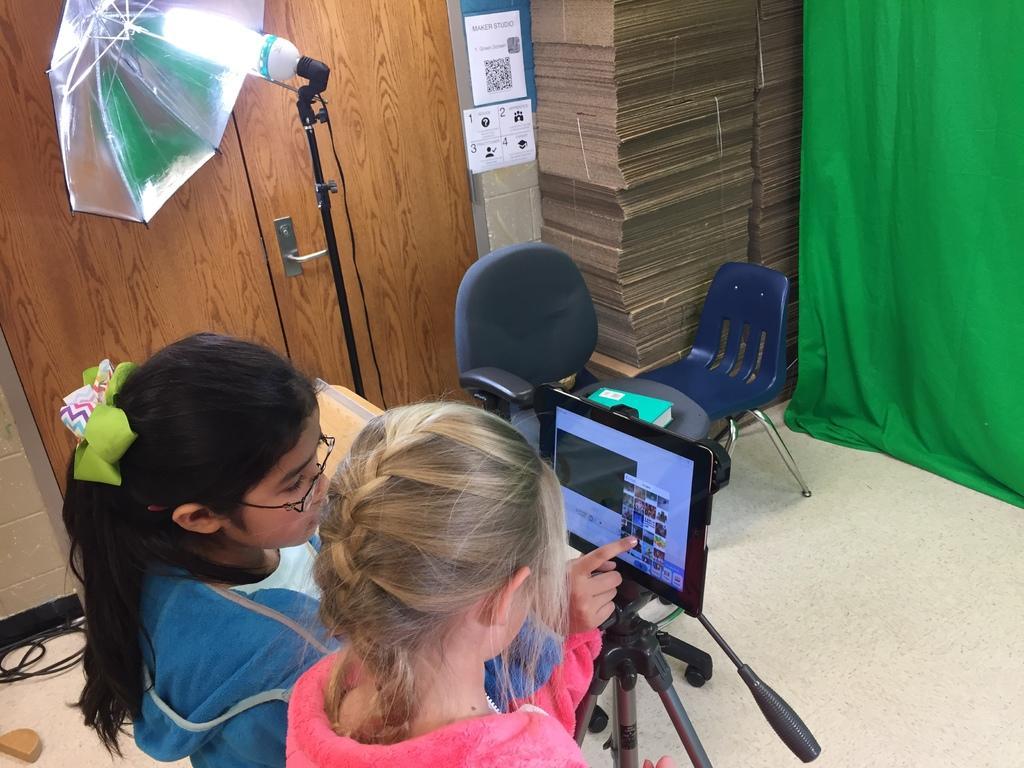In one or two sentences, can you explain what this image depicts? This 2 girls are looking at tab which is on tripod. In the background there is a door,an umbrella,light,chairs,wall and a curtain. 